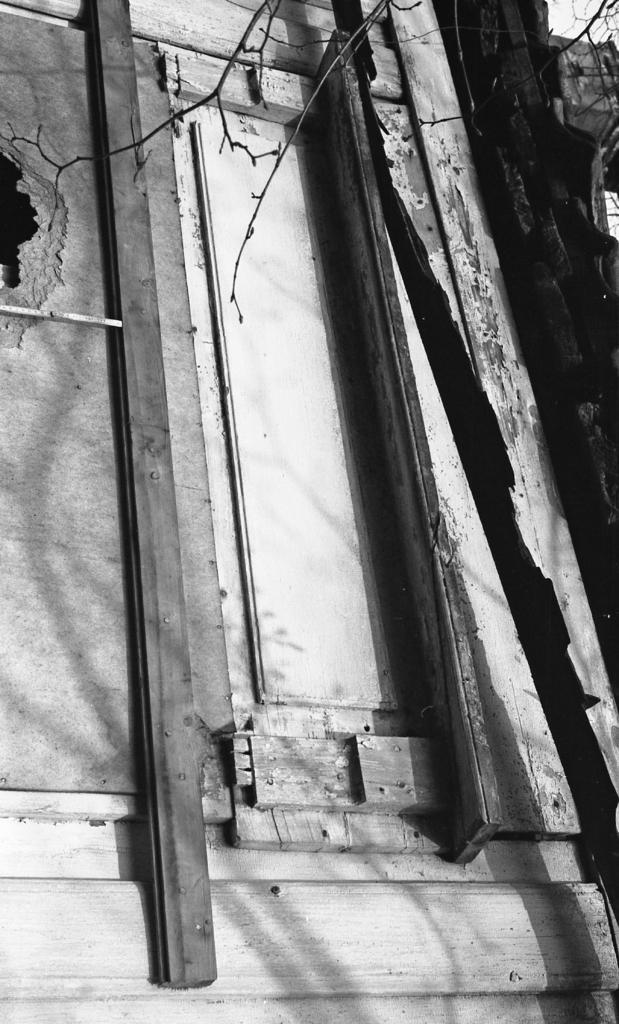How would you summarize this image in a sentence or two? This is a black and white picture. Here we can see a wooden door and branches. 